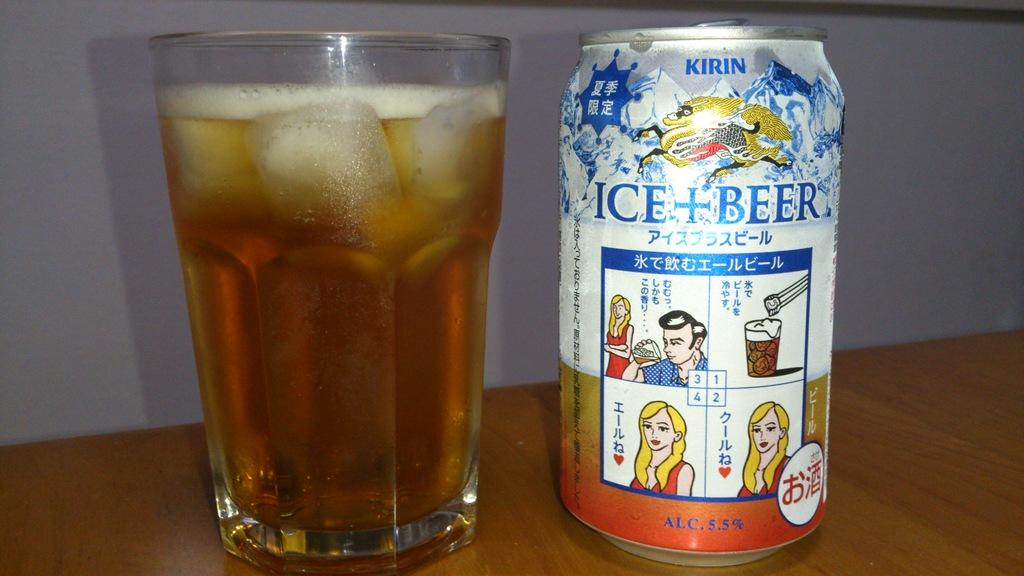<image>
Describe the image concisely. A glass of beer next to a can of Kirin Ice+Beer 